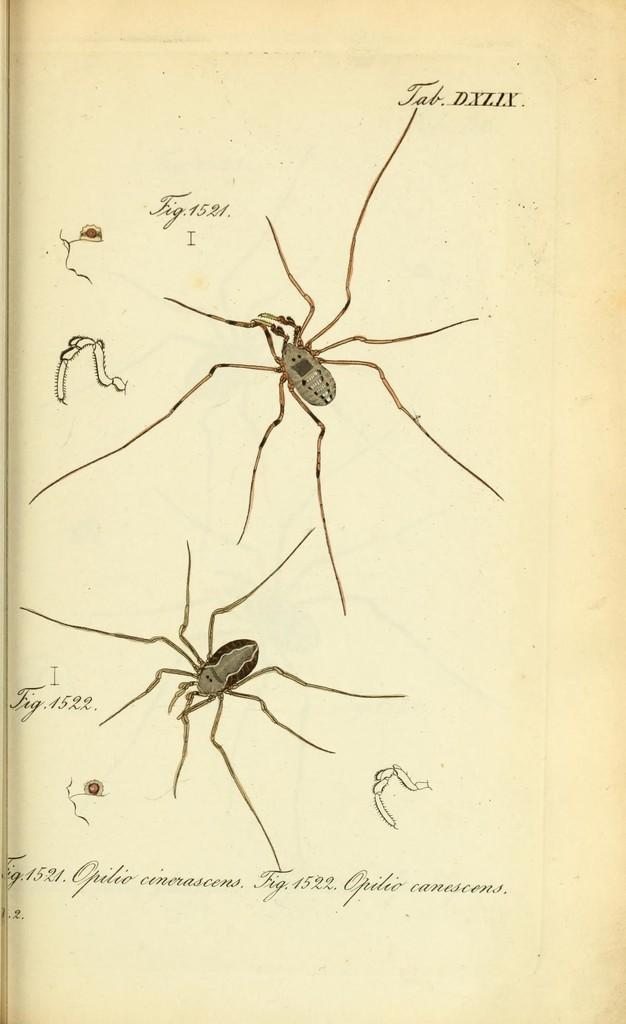Can you describe this image briefly? In this picture I can see a paper on which we can see some images and text. 